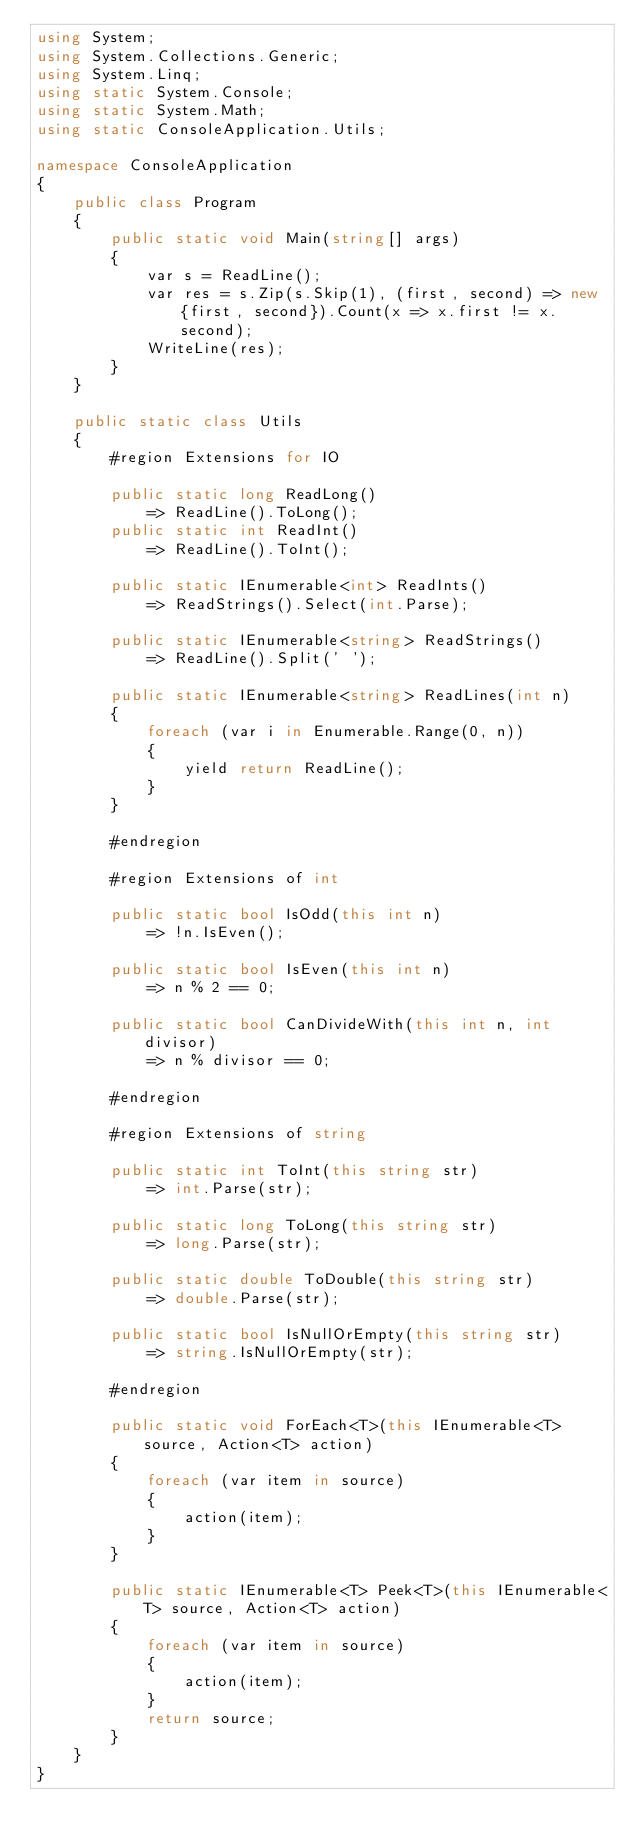Convert code to text. <code><loc_0><loc_0><loc_500><loc_500><_C#_>using System;
using System.Collections.Generic;
using System.Linq;
using static System.Console;
using static System.Math;
using static ConsoleApplication.Utils;

namespace ConsoleApplication
{
    public class Program
    {
        public static void Main(string[] args)
        {
            var s = ReadLine();
            var res = s.Zip(s.Skip(1), (first, second) => new {first, second}).Count(x => x.first != x.second);
            WriteLine(res);
        }
    }

    public static class Utils
    {
        #region Extensions for IO

        public static long ReadLong()
            => ReadLine().ToLong();
        public static int ReadInt()
            => ReadLine().ToInt();

        public static IEnumerable<int> ReadInts()
            => ReadStrings().Select(int.Parse);

        public static IEnumerable<string> ReadStrings()
            => ReadLine().Split(' ');

        public static IEnumerable<string> ReadLines(int n)
        {
            foreach (var i in Enumerable.Range(0, n))
            {
                yield return ReadLine();
            }
        }

        #endregion

        #region Extensions of int

        public static bool IsOdd(this int n)
            => !n.IsEven();

        public static bool IsEven(this int n)
            => n % 2 == 0;

        public static bool CanDivideWith(this int n, int divisor)
            => n % divisor == 0;

        #endregion

        #region Extensions of string

        public static int ToInt(this string str)
            => int.Parse(str);

        public static long ToLong(this string str)
            => long.Parse(str);

        public static double ToDouble(this string str)
            => double.Parse(str);

        public static bool IsNullOrEmpty(this string str)
            => string.IsNullOrEmpty(str);

        #endregion

        public static void ForEach<T>(this IEnumerable<T> source, Action<T> action)
        {
            foreach (var item in source)
            {
                action(item);
            }
        }

        public static IEnumerable<T> Peek<T>(this IEnumerable<T> source, Action<T> action)
        {
            foreach (var item in source)
            {
                action(item);
            }
            return source;
        }
    }
}
</code> 